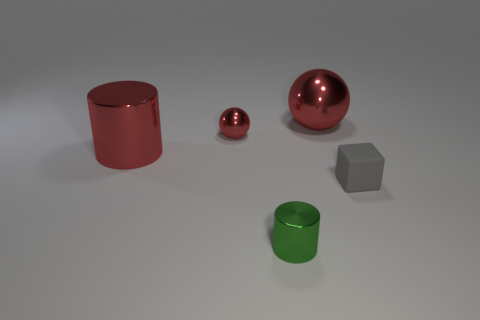What number of other objects are there of the same shape as the small green shiny object?
Keep it short and to the point. 1. There is a cube that is the same size as the green shiny cylinder; what is its color?
Keep it short and to the point. Gray. What number of balls are small metal things or matte things?
Your response must be concise. 1. What number of tiny purple metallic cubes are there?
Offer a very short reply. 0. Does the small red thing have the same shape as the thing in front of the gray rubber object?
Offer a terse response. No. What is the size of the other metal ball that is the same color as the large sphere?
Your response must be concise. Small. How many things are either tiny yellow balls or metal spheres?
Your answer should be very brief. 2. What is the shape of the large shiny thing left of the cylinder that is in front of the rubber cube?
Your response must be concise. Cylinder. There is a big metallic object that is in front of the big metal ball; does it have the same shape as the small rubber thing?
Keep it short and to the point. No. What size is the green cylinder that is the same material as the large red cylinder?
Your answer should be very brief. Small. 